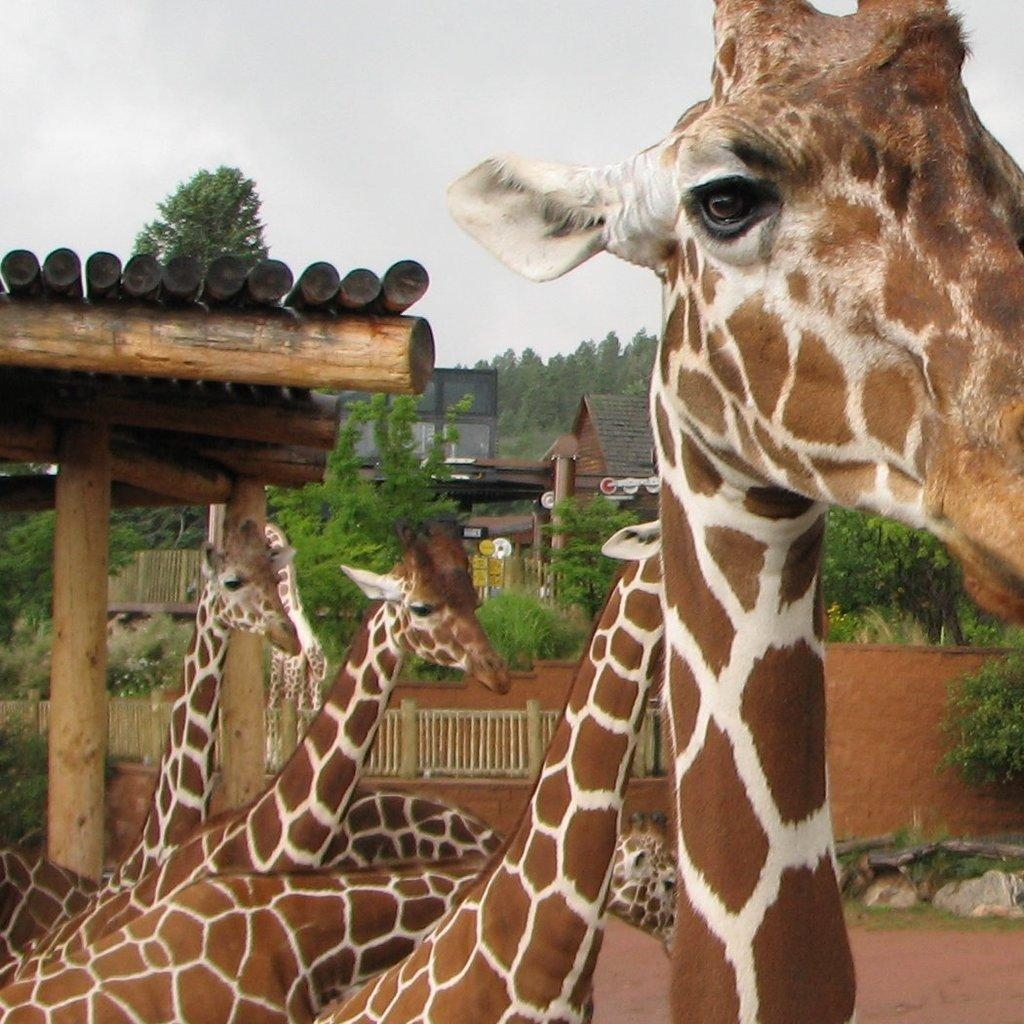What animals can be seen in the image? There are giraffes in the image. What type of structure is present in the image? There is a shed made up of wooden logs in the image. What can be seen in the background of the image? There are trees and houses in the background of the image. What type of plate is hanging on the wall in the image? There is no plate present in the image; it features giraffes, a wooden log shed, trees, and houses in the background. 